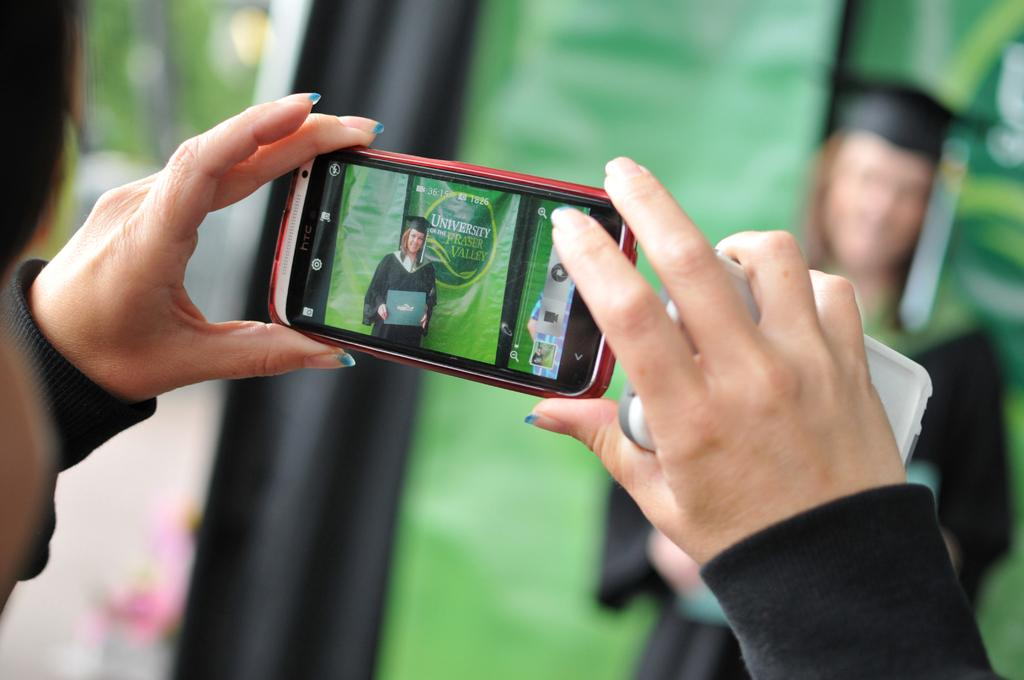<image>
Provide a brief description of the given image. a phone with the word university on it 